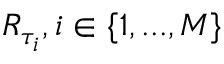Convert formula to latex. <formula><loc_0><loc_0><loc_500><loc_500>R _ { \tau _ { i } } , i \in \{ 1 , \dots , M \}</formula> 